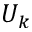Convert formula to latex. <formula><loc_0><loc_0><loc_500><loc_500>U _ { k }</formula> 